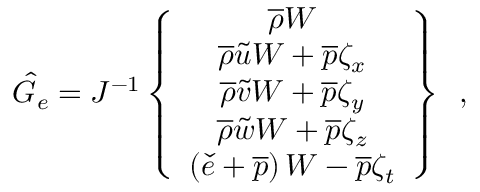<formula> <loc_0><loc_0><loc_500><loc_500>\hat { G } _ { e } = J ^ { - 1 } \left \{ \begin{array} { c } { \overline { \rho } W } \\ { \overline { \rho } \tilde { u } W + \overline { p } \zeta _ { x } } \\ { \overline { \rho } \tilde { v } W + \overline { p } \zeta _ { y } } \\ { \overline { \rho } \tilde { w } W + \overline { p } \zeta _ { z } } \\ { \left ( \check { e } + \overline { p } \right ) W - \overline { p } \zeta _ { t } } \end{array} \right \} \, ,</formula> 